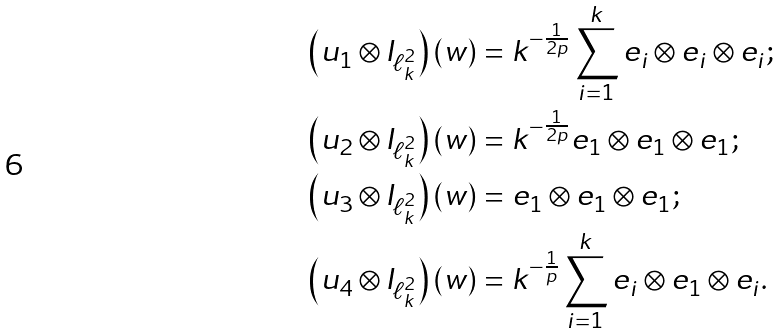Convert formula to latex. <formula><loc_0><loc_0><loc_500><loc_500>\left ( u _ { 1 } \otimes I _ { \ell _ { k } ^ { 2 } } \right ) ( w ) & = k ^ { - \frac { 1 } { 2 p } } \sum _ { i = 1 } ^ { k } e _ { i } \otimes e _ { i } \otimes e _ { i } ; \\ \left ( u _ { 2 } \otimes I _ { \ell _ { k } ^ { 2 } } \right ) ( w ) & = k ^ { - \frac { 1 } { 2 p } } e _ { 1 } \otimes e _ { 1 } \otimes e _ { 1 } ; \\ \left ( u _ { 3 } \otimes I _ { \ell _ { k } ^ { 2 } } \right ) ( w ) & = e _ { 1 } \otimes e _ { 1 } \otimes e _ { 1 } ; \\ \left ( u _ { 4 } \otimes I _ { \ell _ { k } ^ { 2 } } \right ) ( w ) & = k ^ { - \frac { 1 } { p } } \sum _ { i = 1 } ^ { k } e _ { i } \otimes e _ { 1 } \otimes e _ { i } .</formula> 